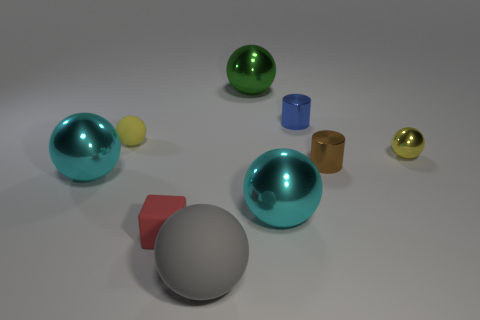Do the cylinder on the right side of the blue cylinder and the big green shiny object have the same size?
Your answer should be compact. No. How big is the gray ball?
Keep it short and to the point. Large. Are there any matte objects of the same color as the small shiny sphere?
Your answer should be compact. Yes. How many large objects are either cyan objects or green metallic balls?
Provide a succinct answer. 3. There is a rubber object that is to the right of the tiny yellow rubber ball and behind the gray matte thing; what is its size?
Offer a very short reply. Small. How many yellow balls are on the left side of the red block?
Keep it short and to the point. 1. The small object that is both behind the brown cylinder and in front of the small yellow rubber object has what shape?
Provide a succinct answer. Sphere. There is a thing that is the same color as the small metallic ball; what material is it?
Give a very brief answer. Rubber. What number of cylinders are large gray objects or red things?
Keep it short and to the point. 0. There is a thing that is the same color as the tiny rubber ball; what size is it?
Your answer should be compact. Small. 